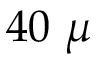Convert formula to latex. <formula><loc_0><loc_0><loc_500><loc_500>4 0 \ \mu</formula> 